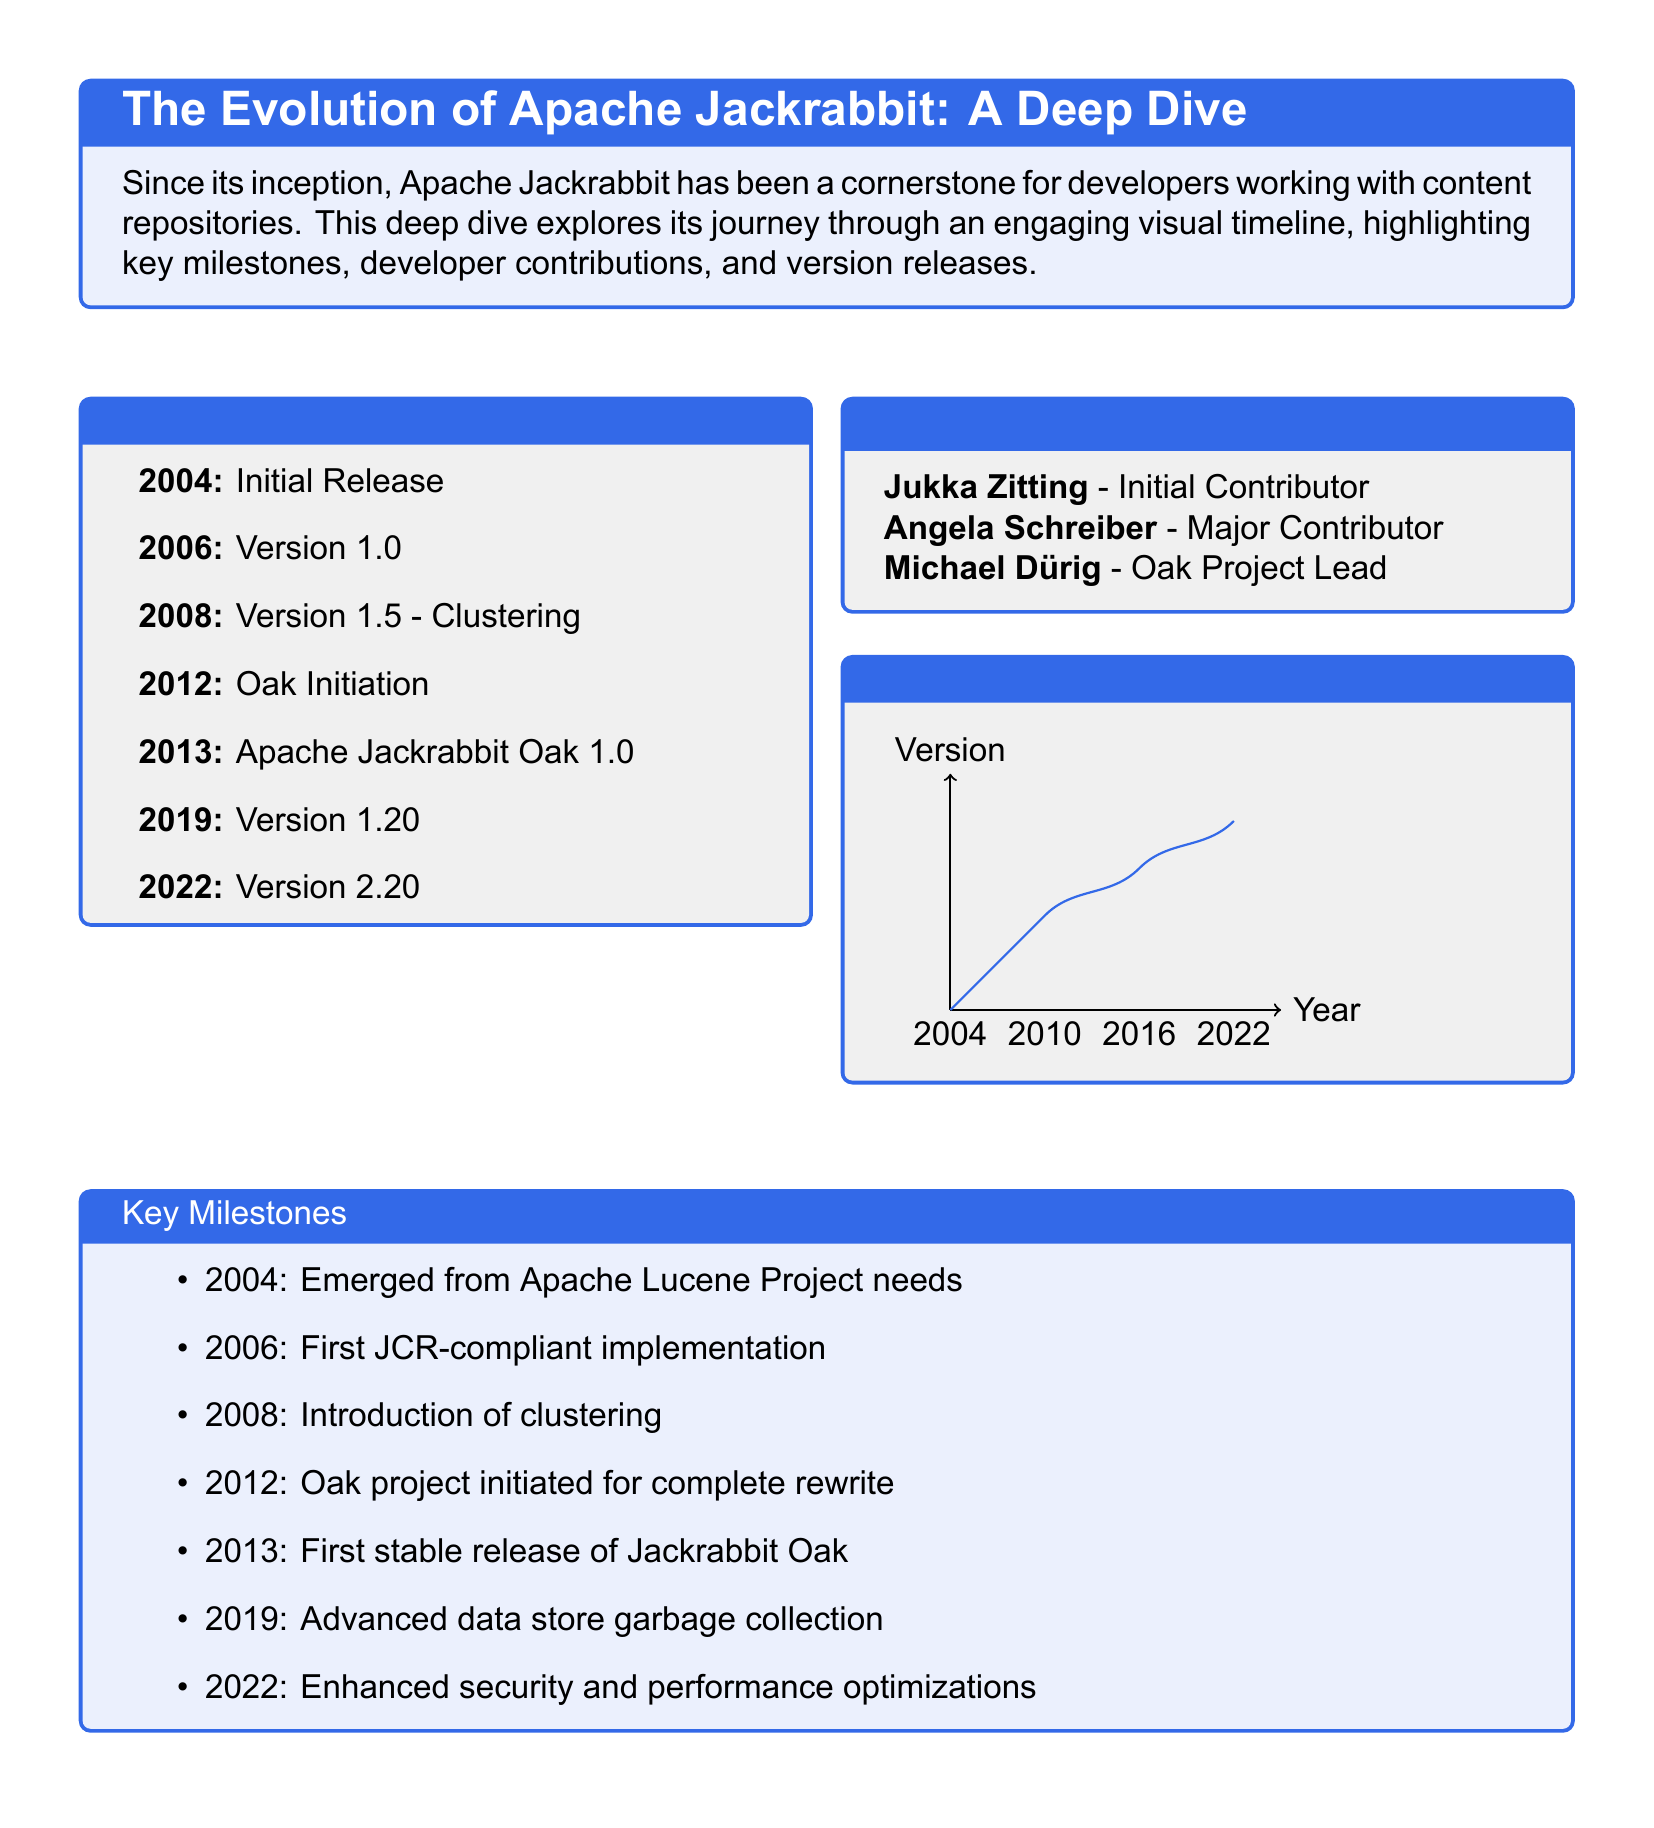What year was Apache Jackrabbit initially released? The initial release year is stated in the timeline, which is 2004.
Answer: 2004 Who is the Oak project lead? The document lists the developers and identifies Michael Dürig as the Oak Project Lead.
Answer: Michael Dürig What version was introduced in 2008? The timeline mentions that the version introduced in 2008 is 1.5, which included clustering.
Answer: 1.5 In what year did Jackrabbit Oak have its first stable release? The timeline indicates that the first stable release of Jackrabbit Oak occurred in 2013.
Answer: 2013 How many key milestones are highlighted? The key milestones section lists a total of seven important milestones in its history.
Answer: Seven What significant feature was added in Jackrabbit version 1.5? The document states that clustering was the significant feature introduced in version 1.5.
Answer: Clustering What is the color scheme used for the document's title box? The title box features a background color that is a shade of blue, specified as apacheblue.
Answer: Apacheblue What type of document structure is utilized in this layout? The document employs a magazine layout with visual elements like timelines and boxes to present information clearly.
Answer: Magazine layout 